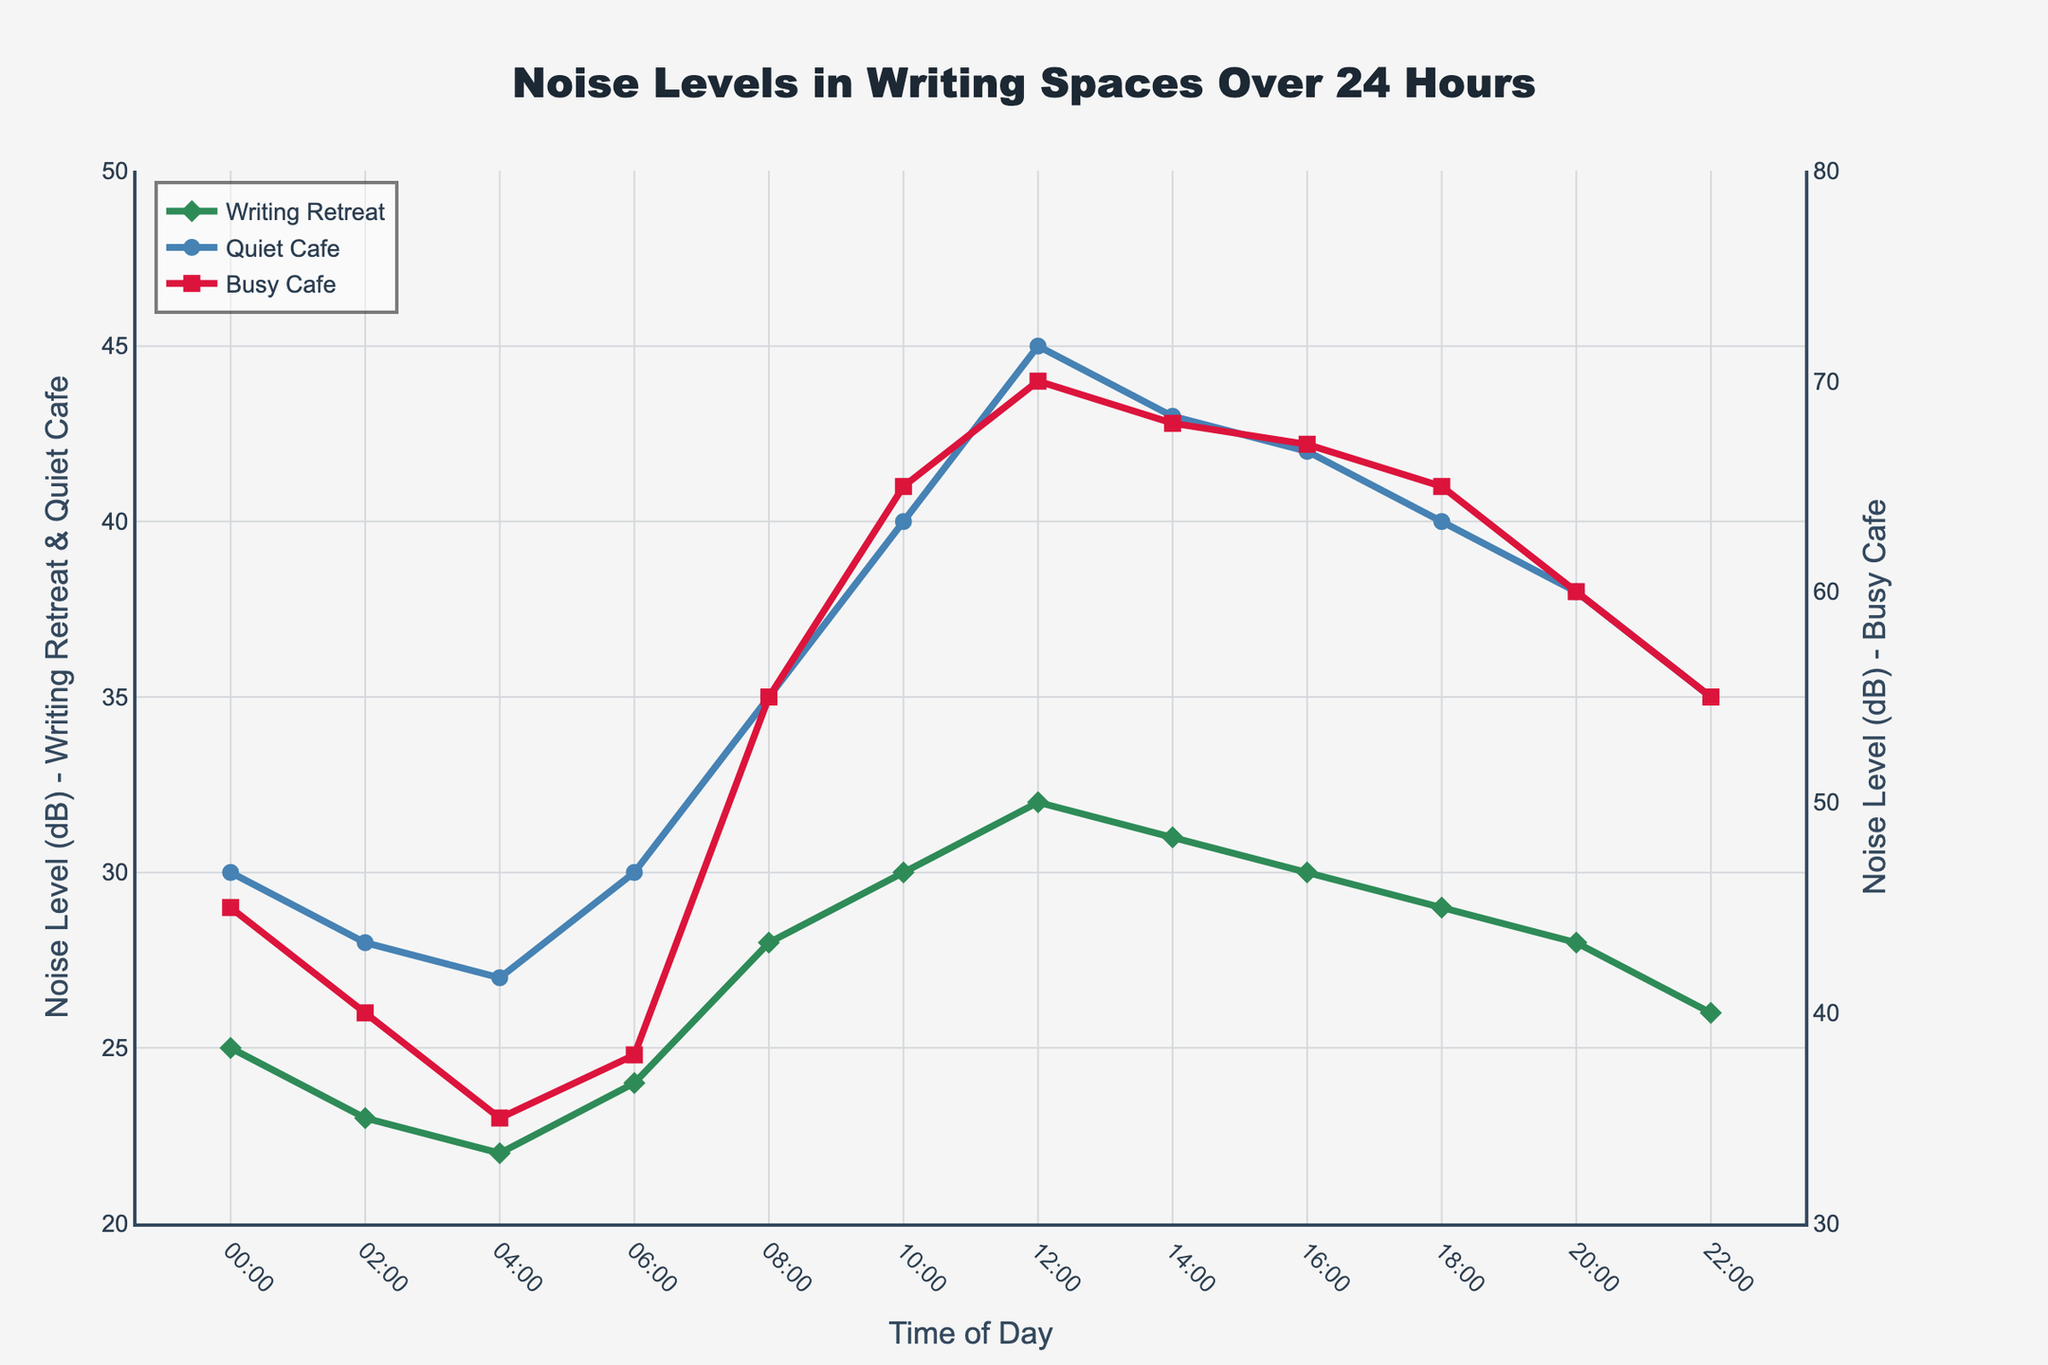What time period has the lowest noise level in the Writing Retreat? By looking at the green diamond markers on the chart, find the point with the lowest y-value. The lowest point is at 04:00.
Answer: 04:00 Which venue shows the highest noise level overall, and at what time does this occur? A comparison of all lines reveals the Busy Cafe peaks at 12:00 with a red square marker reaching a maximum noise level of 70 dB.
Answer: Busy Cafe at 12:00 When comparing 08:00 and 20:00, which time period has quieter noise levels in the Busy Cafe? Look at the red squares for these time points and compare their y-values. At 08:00 the noise level is 55 dB, and at 20:00 it is 60 dB. Therefore, it is quieter at 08:00.
Answer: 08:00 What is the difference in noise level between the Quiet Cafe and the Writing Retreat at 10:00? Find the y-values of the blue circle (Quiet Cafe) and green diamond (Writing Retreat) at 10:00 and calculate the difference: 40 dB - 30 dB = 10 dB.
Answer: 10 dB What time period shows the smallest difference in noise levels between the Quiet Cafe and the Writing Retreat? Check the y-values differences for all time points between blue circle and green diamond markers. The smallest difference is between 24 dB (Writing Retreat) and 30 dB (Quiet Cafe) at 06:00 (difference of 6 dB).
Answer: 06:00 Which location's noise levels have the widest range throughout the 24-hour period? Observe the highest and lowest values for each venue. The Busy Cafe ranges from 35 dB to 70 dB, showing a range of 35 dB. The Quiet Cafe ranges from 27 dB to 45 dB (18 dB range), and the Writing Retreat from 22 dB to 32 dB (10 dB range). The Busy Cafe has the widest range.
Answer: Busy Cafe At what time is the Quiet Cafe noisier than the Writing Retreat but quieter than the Busy Cafe? Examine the y-values of all three lines in intervals: At 06:00, 10:00, 12:00, 14:00, 16:00, 18:00, and 20:00 the Quiet Cafe's noise level values are between the Writing Retreat and Busy Cafe.
Answer: Multiple times: 06:00, 10:00, 12:00, 14:00, 16:00, 18:00, 20:00 What is the average noise level of the Writing Retreat between 00:00 and 06:00? Add the noise levels at 00:00, 02:00, 04:00, and 06:00: (25 + 23 + 22 + 24) = 94, then divide by 4 to get the average: 94 / 4 = 23.5 dB.
Answer: 23.5 dB How much higher is the noise level at the Busy Cafe at 18:00 compared to the Quiet Cafe at the same time? Subtract the y-value of the Quiet Cafe (blue circle) from Busy Cafe (red square) at 18:00: 65 dB - 40 dB = 25 dB.
Answer: 25 dB 